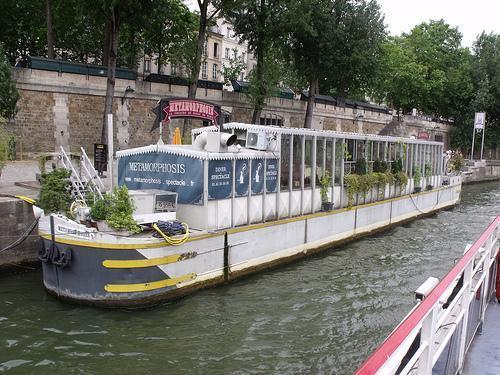How many boats are in the water?
Give a very brief answer. 1. 